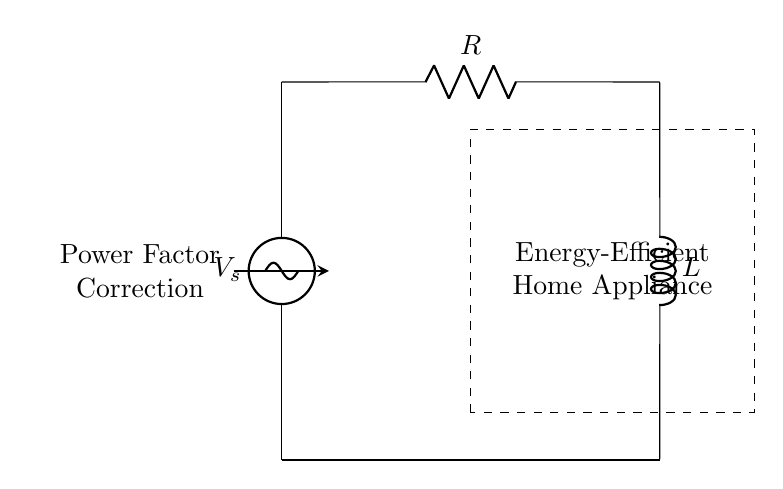What type of circuit is shown? The circuit is a series RL circuit since it consists of a resistor and an inductor connected in series along with a voltage source. This is indicated by the presence of both a resistor and an inductor in the diagram.
Answer: series RL circuit What components are present in the circuit? The components in the circuit are a voltage source, a resistor (labeled R), and an inductor (labeled L). The labels on the components in the diagram clearly show their identities.
Answer: voltage source, resistor, inductor What is the purpose of power factor correction in this circuit? The purpose of power factor correction in this circuit is to improve the efficiency of energy consumption in home appliances by reducing the phase difference between voltage and current. This is indicated by the label "Power Factor Correction" in the diagram.
Answer: improve efficiency What is the role of the resistor in this RL circuit? The role of the resistor in a series RL circuit is to limit the current flowing through the circuit and to dissipate energy as heat. This is a fundamental property of resistors and is evident from their placement in the circuit.
Answer: limit current How does an inductor affect current in this circuit? An inductor affects the current in the circuit by opposing changes in current flow, causing a phase shift in current relative to voltage, which impacts the power factor. The inductance property comes from its position and label (L) in the circuit.
Answer: opposes changes What happens to the power factor if the inductance increases? If the inductance increases in this circuit, the power factor typically decreases, leading to more reactive power due to the greater phase difference between voltage and current. This relationship is fundamental to RL circuits and is influenced by the nature of inductors.
Answer: decreases 